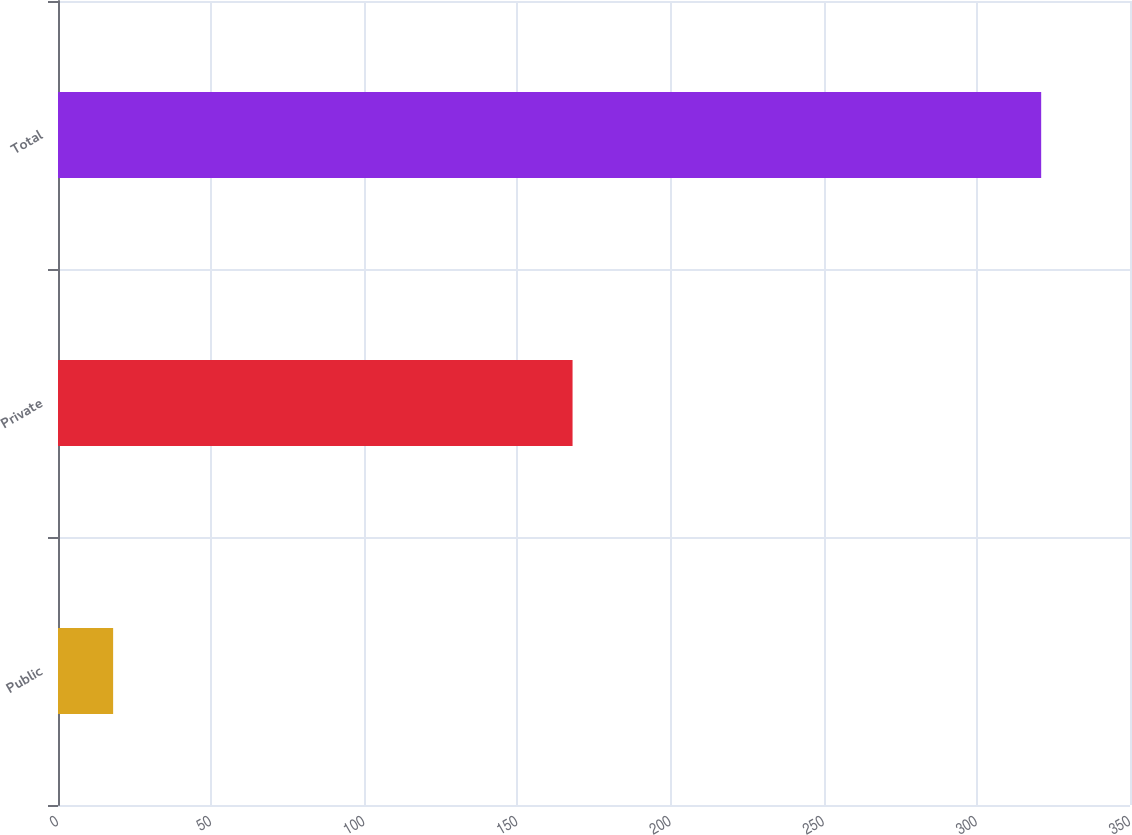<chart> <loc_0><loc_0><loc_500><loc_500><bar_chart><fcel>Public<fcel>Private<fcel>Total<nl><fcel>18<fcel>168<fcel>321<nl></chart> 